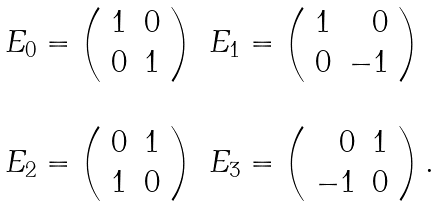<formula> <loc_0><loc_0><loc_500><loc_500>\begin{array} { l l } E _ { 0 } = \left ( \begin{array} { r r } 1 & 0 \\ 0 & 1 \end{array} \right ) & E _ { 1 } = \left ( \begin{array} { r r } 1 & 0 \\ 0 & - 1 \end{array} \right ) \\ \ & \ \\ E _ { 2 } = \left ( \begin{array} { r r } 0 & 1 \\ 1 & 0 \end{array} \right ) & E _ { 3 } = \left ( \begin{array} { r r } 0 & 1 \\ - 1 & 0 \end{array} \right ) . \end{array}</formula> 